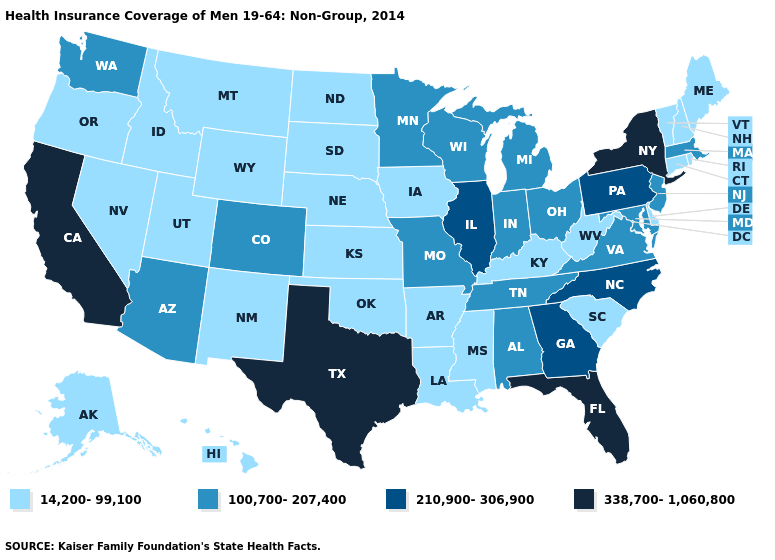Name the states that have a value in the range 14,200-99,100?
Concise answer only. Alaska, Arkansas, Connecticut, Delaware, Hawaii, Idaho, Iowa, Kansas, Kentucky, Louisiana, Maine, Mississippi, Montana, Nebraska, Nevada, New Hampshire, New Mexico, North Dakota, Oklahoma, Oregon, Rhode Island, South Carolina, South Dakota, Utah, Vermont, West Virginia, Wyoming. What is the value of Indiana?
Give a very brief answer. 100,700-207,400. What is the highest value in states that border Louisiana?
Be succinct. 338,700-1,060,800. Does Maryland have the lowest value in the USA?
Write a very short answer. No. Name the states that have a value in the range 14,200-99,100?
Quick response, please. Alaska, Arkansas, Connecticut, Delaware, Hawaii, Idaho, Iowa, Kansas, Kentucky, Louisiana, Maine, Mississippi, Montana, Nebraska, Nevada, New Hampshire, New Mexico, North Dakota, Oklahoma, Oregon, Rhode Island, South Carolina, South Dakota, Utah, Vermont, West Virginia, Wyoming. Which states hav the highest value in the Northeast?
Give a very brief answer. New York. Name the states that have a value in the range 338,700-1,060,800?
Answer briefly. California, Florida, New York, Texas. Does North Carolina have the lowest value in the South?
Quick response, please. No. Does Colorado have the highest value in the USA?
Short answer required. No. Name the states that have a value in the range 100,700-207,400?
Concise answer only. Alabama, Arizona, Colorado, Indiana, Maryland, Massachusetts, Michigan, Minnesota, Missouri, New Jersey, Ohio, Tennessee, Virginia, Washington, Wisconsin. Which states have the lowest value in the USA?
Keep it brief. Alaska, Arkansas, Connecticut, Delaware, Hawaii, Idaho, Iowa, Kansas, Kentucky, Louisiana, Maine, Mississippi, Montana, Nebraska, Nevada, New Hampshire, New Mexico, North Dakota, Oklahoma, Oregon, Rhode Island, South Carolina, South Dakota, Utah, Vermont, West Virginia, Wyoming. Name the states that have a value in the range 14,200-99,100?
Write a very short answer. Alaska, Arkansas, Connecticut, Delaware, Hawaii, Idaho, Iowa, Kansas, Kentucky, Louisiana, Maine, Mississippi, Montana, Nebraska, Nevada, New Hampshire, New Mexico, North Dakota, Oklahoma, Oregon, Rhode Island, South Carolina, South Dakota, Utah, Vermont, West Virginia, Wyoming. What is the value of Montana?
Concise answer only. 14,200-99,100. Which states have the lowest value in the USA?
Keep it brief. Alaska, Arkansas, Connecticut, Delaware, Hawaii, Idaho, Iowa, Kansas, Kentucky, Louisiana, Maine, Mississippi, Montana, Nebraska, Nevada, New Hampshire, New Mexico, North Dakota, Oklahoma, Oregon, Rhode Island, South Carolina, South Dakota, Utah, Vermont, West Virginia, Wyoming. What is the value of North Dakota?
Keep it brief. 14,200-99,100. 